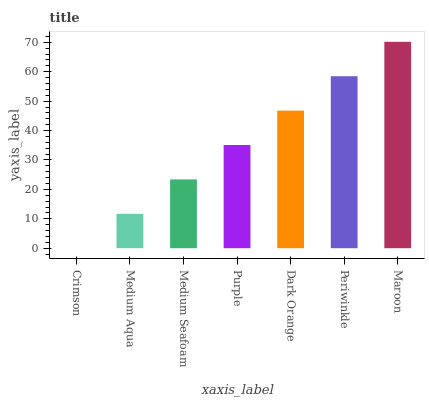Is Crimson the minimum?
Answer yes or no. Yes. Is Maroon the maximum?
Answer yes or no. Yes. Is Medium Aqua the minimum?
Answer yes or no. No. Is Medium Aqua the maximum?
Answer yes or no. No. Is Medium Aqua greater than Crimson?
Answer yes or no. Yes. Is Crimson less than Medium Aqua?
Answer yes or no. Yes. Is Crimson greater than Medium Aqua?
Answer yes or no. No. Is Medium Aqua less than Crimson?
Answer yes or no. No. Is Purple the high median?
Answer yes or no. Yes. Is Purple the low median?
Answer yes or no. Yes. Is Medium Aqua the high median?
Answer yes or no. No. Is Crimson the low median?
Answer yes or no. No. 